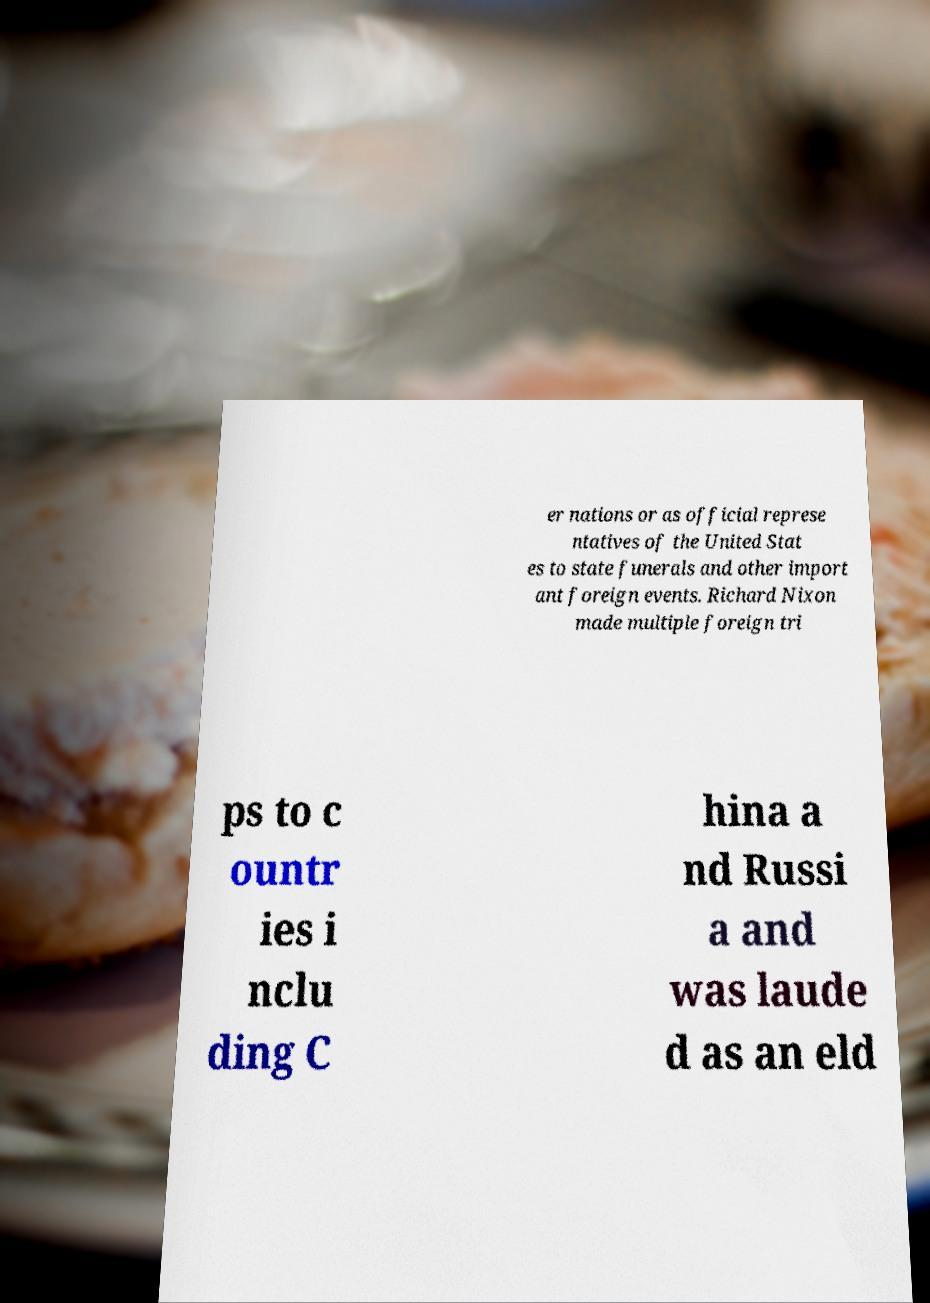Can you accurately transcribe the text from the provided image for me? er nations or as official represe ntatives of the United Stat es to state funerals and other import ant foreign events. Richard Nixon made multiple foreign tri ps to c ountr ies i nclu ding C hina a nd Russi a and was laude d as an eld 